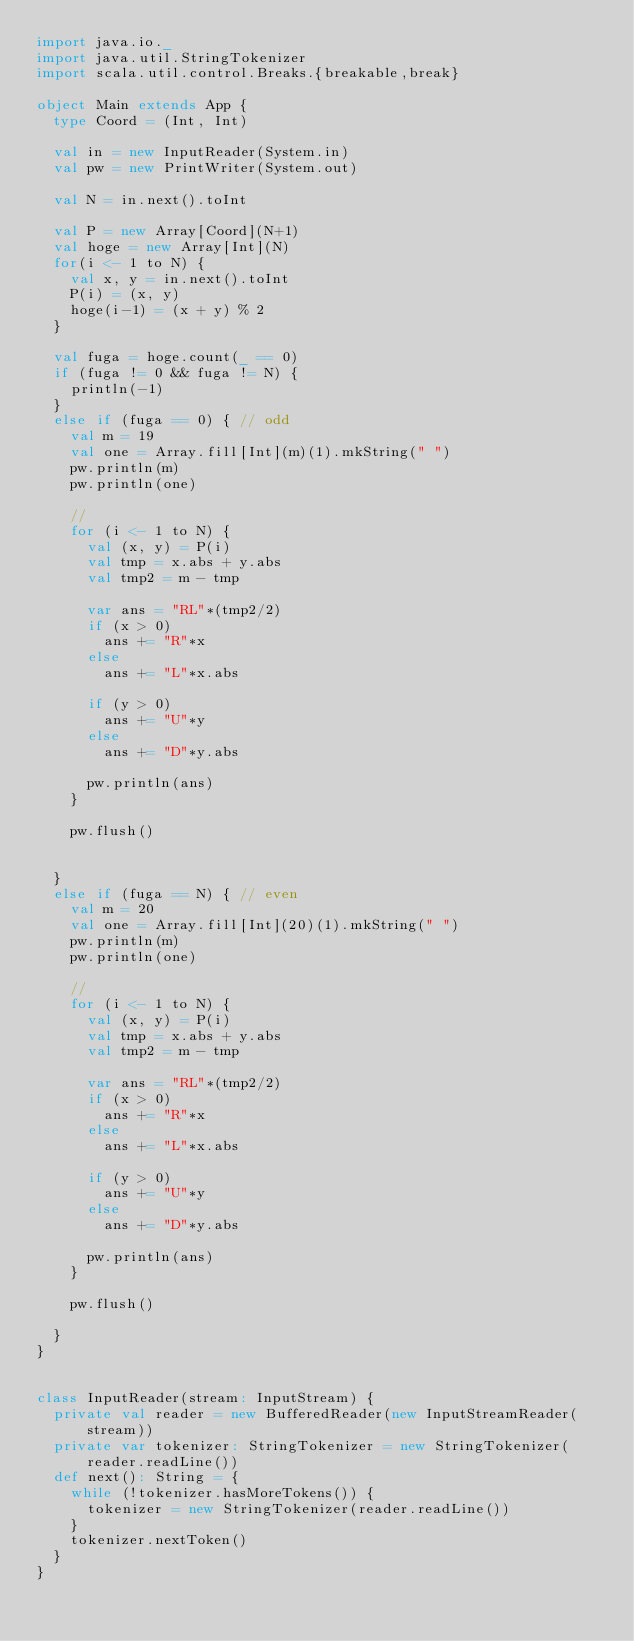<code> <loc_0><loc_0><loc_500><loc_500><_Scala_>import java.io._
import java.util.StringTokenizer
import scala.util.control.Breaks.{breakable,break}

object Main extends App {
  type Coord = (Int, Int)

  val in = new InputReader(System.in)
  val pw = new PrintWriter(System.out)

  val N = in.next().toInt

  val P = new Array[Coord](N+1)
  val hoge = new Array[Int](N)
  for(i <- 1 to N) {
    val x, y = in.next().toInt
    P(i) = (x, y)
    hoge(i-1) = (x + y) % 2
  }

  val fuga = hoge.count(_ == 0)
  if (fuga != 0 && fuga != N) {
    println(-1)
  }
  else if (fuga == 0) { // odd
    val m = 19
    val one = Array.fill[Int](m)(1).mkString(" ")
    pw.println(m)
    pw.println(one)

    //
    for (i <- 1 to N) {
      val (x, y) = P(i)
      val tmp = x.abs + y.abs
      val tmp2 = m - tmp

      var ans = "RL"*(tmp2/2)
      if (x > 0)
        ans += "R"*x
      else
        ans += "L"*x.abs

      if (y > 0)
        ans += "U"*y
      else
        ans += "D"*y.abs

      pw.println(ans)
    }

    pw.flush()


  }
  else if (fuga == N) { // even
    val m = 20
    val one = Array.fill[Int](20)(1).mkString(" ")
    pw.println(m)
    pw.println(one)

    //
    for (i <- 1 to N) {
      val (x, y) = P(i)
      val tmp = x.abs + y.abs
      val tmp2 = m - tmp

      var ans = "RL"*(tmp2/2)
      if (x > 0)
        ans += "R"*x
      else
        ans += "L"*x.abs

      if (y > 0)
        ans += "U"*y
      else
        ans += "D"*y.abs

      pw.println(ans)
    }

    pw.flush()

  }
}


class InputReader(stream: InputStream) {
  private val reader = new BufferedReader(new InputStreamReader(stream))
  private var tokenizer: StringTokenizer = new StringTokenizer(reader.readLine())
  def next(): String = {
    while (!tokenizer.hasMoreTokens()) {
      tokenizer = new StringTokenizer(reader.readLine())
    }
    tokenizer.nextToken()
  }
}
</code> 